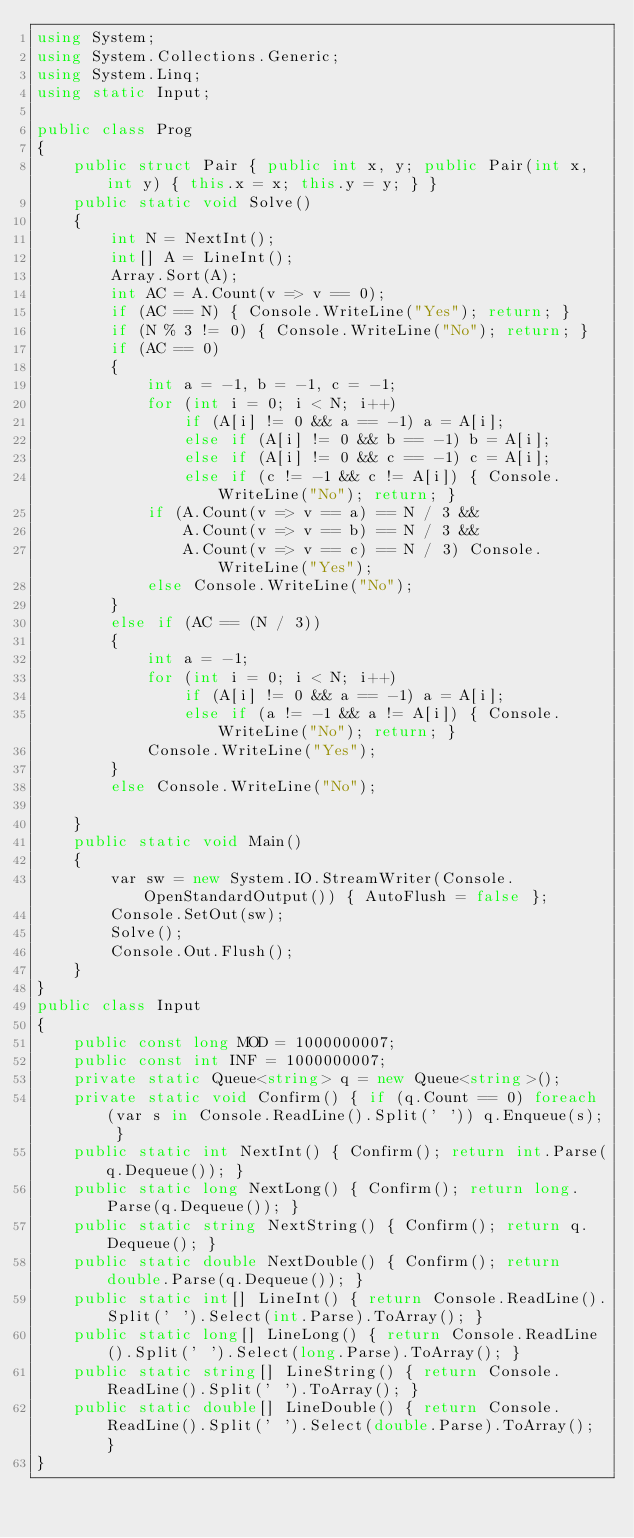Convert code to text. <code><loc_0><loc_0><loc_500><loc_500><_C#_>using System;
using System.Collections.Generic;
using System.Linq;
using static Input;

public class Prog
{
    public struct Pair { public int x, y; public Pair(int x, int y) { this.x = x; this.y = y; } }
    public static void Solve()
    {
        int N = NextInt();
        int[] A = LineInt();
        Array.Sort(A);
        int AC = A.Count(v => v == 0);
        if (AC == N) { Console.WriteLine("Yes"); return; }
        if (N % 3 != 0) { Console.WriteLine("No"); return; }
        if (AC == 0)
        {
            int a = -1, b = -1, c = -1;
            for (int i = 0; i < N; i++)
                if (A[i] != 0 && a == -1) a = A[i];
                else if (A[i] != 0 && b == -1) b = A[i];
                else if (A[i] != 0 && c == -1) c = A[i];
                else if (c != -1 && c != A[i]) { Console.WriteLine("No"); return; }
            if (A.Count(v => v == a) == N / 3 &&
                A.Count(v => v == b) == N / 3 &&
                A.Count(v => v == c) == N / 3) Console.WriteLine("Yes");
            else Console.WriteLine("No");
        }
        else if (AC == (N / 3))
        {
            int a = -1;
            for (int i = 0; i < N; i++)
                if (A[i] != 0 && a == -1) a = A[i];
                else if (a != -1 && a != A[i]) { Console.WriteLine("No"); return; }
            Console.WriteLine("Yes");
        }
        else Console.WriteLine("No");

    }
    public static void Main()
    {
        var sw = new System.IO.StreamWriter(Console.OpenStandardOutput()) { AutoFlush = false };
        Console.SetOut(sw);
        Solve();
        Console.Out.Flush();
    }
}
public class Input
{
    public const long MOD = 1000000007;
    public const int INF = 1000000007;
    private static Queue<string> q = new Queue<string>();
    private static void Confirm() { if (q.Count == 0) foreach (var s in Console.ReadLine().Split(' ')) q.Enqueue(s); }
    public static int NextInt() { Confirm(); return int.Parse(q.Dequeue()); }
    public static long NextLong() { Confirm(); return long.Parse(q.Dequeue()); }
    public static string NextString() { Confirm(); return q.Dequeue(); }
    public static double NextDouble() { Confirm(); return double.Parse(q.Dequeue()); }
    public static int[] LineInt() { return Console.ReadLine().Split(' ').Select(int.Parse).ToArray(); }
    public static long[] LineLong() { return Console.ReadLine().Split(' ').Select(long.Parse).ToArray(); }
    public static string[] LineString() { return Console.ReadLine().Split(' ').ToArray(); }
    public static double[] LineDouble() { return Console.ReadLine().Split(' ').Select(double.Parse).ToArray(); }
}
</code> 